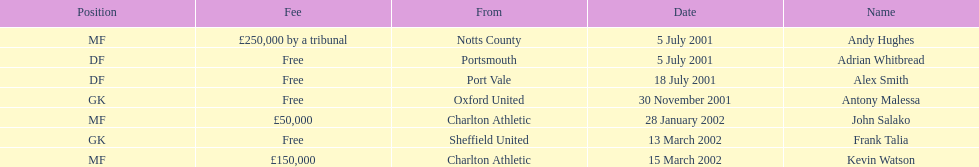Who transferred after 30 november 2001? John Salako, Frank Talia, Kevin Watson. I'm looking to parse the entire table for insights. Could you assist me with that? {'header': ['Position', 'Fee', 'From', 'Date', 'Name'], 'rows': [['MF', '£250,000 by a tribunal', 'Notts County', '5 July 2001', 'Andy Hughes'], ['DF', 'Free', 'Portsmouth', '5 July 2001', 'Adrian Whitbread'], ['DF', 'Free', 'Port Vale', '18 July 2001', 'Alex Smith'], ['GK', 'Free', 'Oxford United', '30 November 2001', 'Antony Malessa'], ['MF', '£50,000', 'Charlton Athletic', '28 January 2002', 'John Salako'], ['GK', 'Free', 'Sheffield United', '13 March 2002', 'Frank Talia'], ['MF', '£150,000', 'Charlton Athletic', '15 March 2002', 'Kevin Watson']]} 